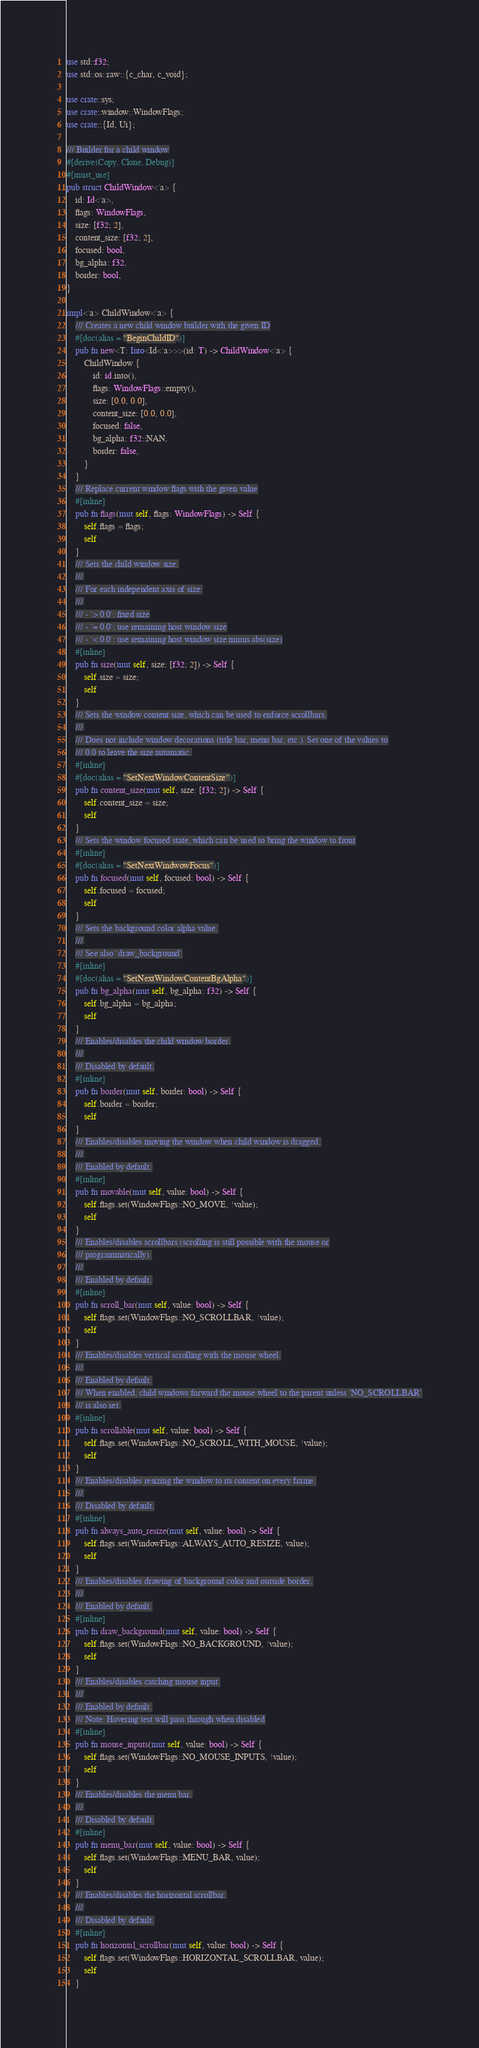Convert code to text. <code><loc_0><loc_0><loc_500><loc_500><_Rust_>use std::f32;
use std::os::raw::{c_char, c_void};

use crate::sys;
use crate::window::WindowFlags;
use crate::{Id, Ui};

/// Builder for a child window
#[derive(Copy, Clone, Debug)]
#[must_use]
pub struct ChildWindow<'a> {
    id: Id<'a>,
    flags: WindowFlags,
    size: [f32; 2],
    content_size: [f32; 2],
    focused: bool,
    bg_alpha: f32,
    border: bool,
}

impl<'a> ChildWindow<'a> {
    /// Creates a new child window builder with the given ID
    #[doc(alias = "BeginChildID")]
    pub fn new<T: Into<Id<'a>>>(id: T) -> ChildWindow<'a> {
        ChildWindow {
            id: id.into(),
            flags: WindowFlags::empty(),
            size: [0.0, 0.0],
            content_size: [0.0, 0.0],
            focused: false,
            bg_alpha: f32::NAN,
            border: false,
        }
    }
    /// Replace current window flags with the given value
    #[inline]
    pub fn flags(mut self, flags: WindowFlags) -> Self {
        self.flags = flags;
        self
    }
    /// Sets the child window size.
    ///
    /// For each independent axis of size:
    ///
    /// - `> 0.0`: fixed size
    /// - `= 0.0`: use remaining host window size
    /// - `< 0.0`: use remaining host window size minus abs(size)
    #[inline]
    pub fn size(mut self, size: [f32; 2]) -> Self {
        self.size = size;
        self
    }
    /// Sets the window content size, which can be used to enforce scrollbars.
    ///
    /// Does not include window decorations (title bar, menu bar, etc.). Set one of the values to
    /// 0.0 to leave the size automatic.
    #[inline]
    #[doc(alias = "SetNextWindowContentSize")]
    pub fn content_size(mut self, size: [f32; 2]) -> Self {
        self.content_size = size;
        self
    }
    /// Sets the window focused state, which can be used to bring the window to front
    #[inline]
    #[doc(alias = "SetNextWindwowFocus")]
    pub fn focused(mut self, focused: bool) -> Self {
        self.focused = focused;
        self
    }
    /// Sets the background color alpha value.
    ///
    /// See also `draw_background`
    #[inline]
    #[doc(alias = "SetNextWindowContentBgAlpha")]
    pub fn bg_alpha(mut self, bg_alpha: f32) -> Self {
        self.bg_alpha = bg_alpha;
        self
    }
    /// Enables/disables the child window border.
    ///
    /// Disabled by default.
    #[inline]
    pub fn border(mut self, border: bool) -> Self {
        self.border = border;
        self
    }
    /// Enables/disables moving the window when child window is dragged.
    ///
    /// Enabled by default.
    #[inline]
    pub fn movable(mut self, value: bool) -> Self {
        self.flags.set(WindowFlags::NO_MOVE, !value);
        self
    }
    /// Enables/disables scrollbars (scrolling is still possible with the mouse or
    /// programmatically).
    ///
    /// Enabled by default.
    #[inline]
    pub fn scroll_bar(mut self, value: bool) -> Self {
        self.flags.set(WindowFlags::NO_SCROLLBAR, !value);
        self
    }
    /// Enables/disables vertical scrolling with the mouse wheel.
    ///
    /// Enabled by default.
    /// When enabled, child windows forward the mouse wheel to the parent unless `NO_SCROLLBAR`
    /// is also set.
    #[inline]
    pub fn scrollable(mut self, value: bool) -> Self {
        self.flags.set(WindowFlags::NO_SCROLL_WITH_MOUSE, !value);
        self
    }
    /// Enables/disables resizing the window to its content on every frame.
    ///
    /// Disabled by default.
    #[inline]
    pub fn always_auto_resize(mut self, value: bool) -> Self {
        self.flags.set(WindowFlags::ALWAYS_AUTO_RESIZE, value);
        self
    }
    /// Enables/disables drawing of background color and outside border.
    ///
    /// Enabled by default.
    #[inline]
    pub fn draw_background(mut self, value: bool) -> Self {
        self.flags.set(WindowFlags::NO_BACKGROUND, !value);
        self
    }
    /// Enables/disables catching mouse input.
    ///
    /// Enabled by default.
    /// Note: Hovering test will pass through when disabled
    #[inline]
    pub fn mouse_inputs(mut self, value: bool) -> Self {
        self.flags.set(WindowFlags::NO_MOUSE_INPUTS, !value);
        self
    }
    /// Enables/disables the menu bar.
    ///
    /// Disabled by default.
    #[inline]
    pub fn menu_bar(mut self, value: bool) -> Self {
        self.flags.set(WindowFlags::MENU_BAR, value);
        self
    }
    /// Enables/disables the horizontal scrollbar.
    ///
    /// Disabled by default.
    #[inline]
    pub fn horizontal_scrollbar(mut self, value: bool) -> Self {
        self.flags.set(WindowFlags::HORIZONTAL_SCROLLBAR, value);
        self
    }</code> 